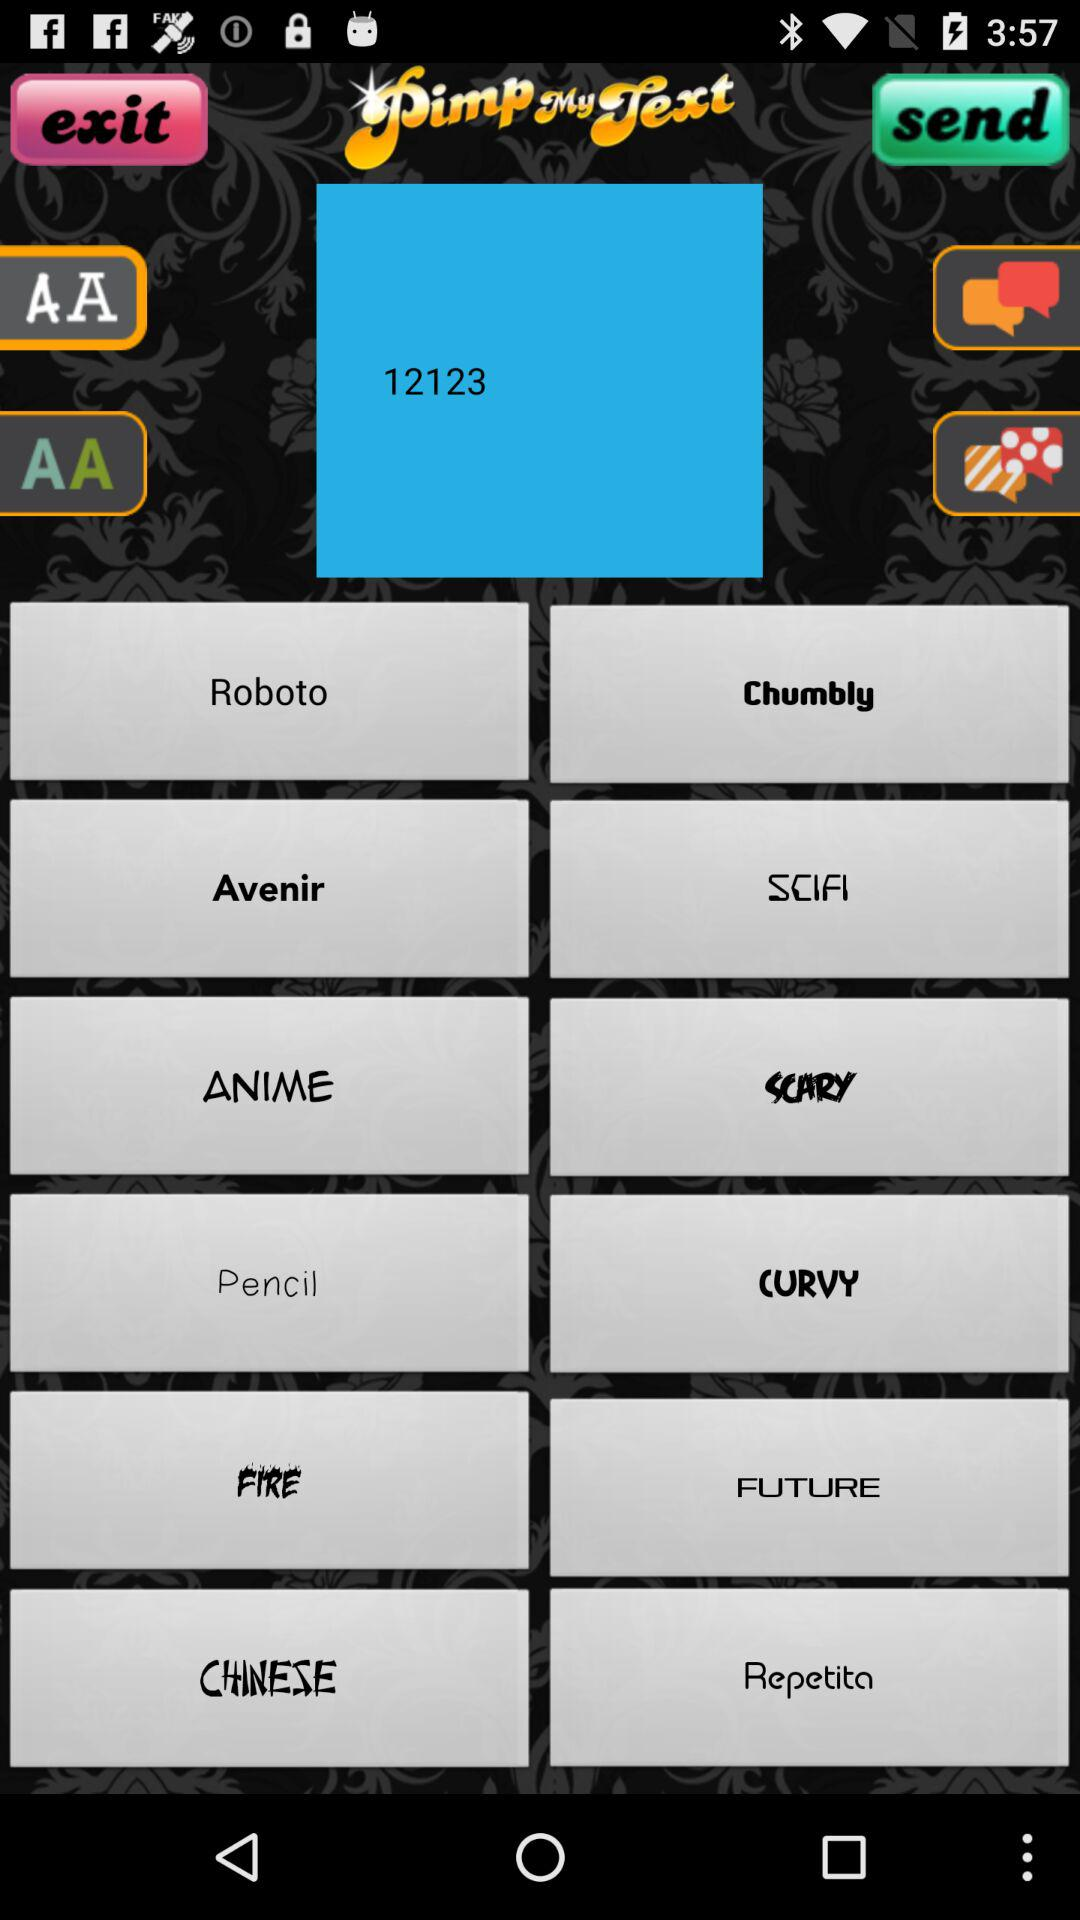What is the application name? The application name is "Pimp My Text". 